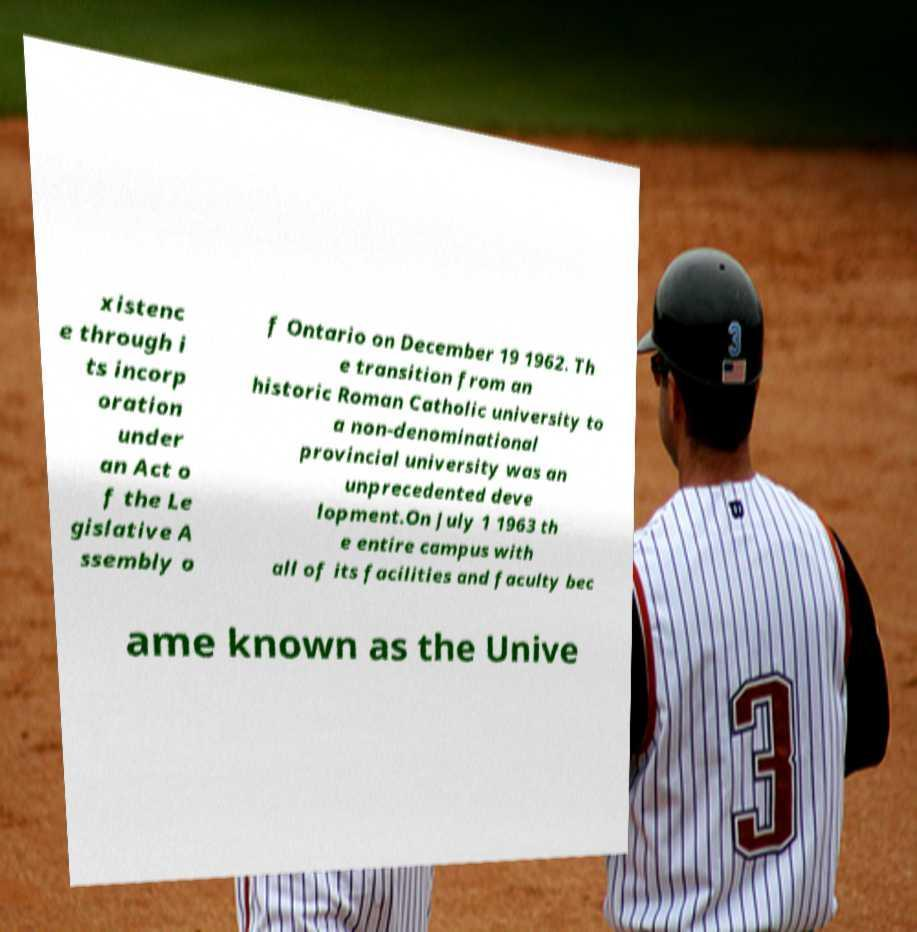I need the written content from this picture converted into text. Can you do that? xistenc e through i ts incorp oration under an Act o f the Le gislative A ssembly o f Ontario on December 19 1962. Th e transition from an historic Roman Catholic university to a non-denominational provincial university was an unprecedented deve lopment.On July 1 1963 th e entire campus with all of its facilities and faculty bec ame known as the Unive 